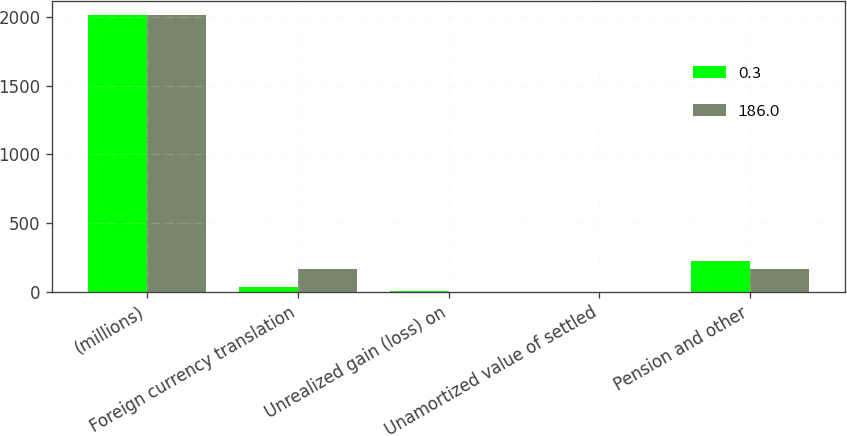Convert chart. <chart><loc_0><loc_0><loc_500><loc_500><stacked_bar_chart><ecel><fcel>(millions)<fcel>Foreign currency translation<fcel>Unrealized gain (loss) on<fcel>Unamortized value of settled<fcel>Pension and other<nl><fcel>0.3<fcel>2014<fcel>32.1<fcel>3<fcel>2.9<fcel>224<nl><fcel>186<fcel>2013<fcel>165.7<fcel>0.3<fcel>2<fcel>167.7<nl></chart> 